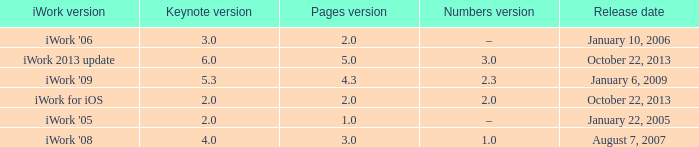What version of iWork was released on October 22, 2013 with a pages version greater than 2? Iwork 2013 update. Could you parse the entire table? {'header': ['iWork version', 'Keynote version', 'Pages version', 'Numbers version', 'Release date'], 'rows': [["iWork '06", '3.0', '2.0', '–', 'January 10, 2006'], ['iWork 2013 update', '6.0', '5.0', '3.0', 'October 22, 2013'], ["iWork '09", '5.3', '4.3', '2.3', 'January 6, 2009'], ['iWork for iOS', '2.0', '2.0', '2.0', 'October 22, 2013'], ["iWork '05", '2.0', '1.0', '–', 'January 22, 2005'], ["iWork '08", '4.0', '3.0', '1.0', 'August 7, 2007']]} 